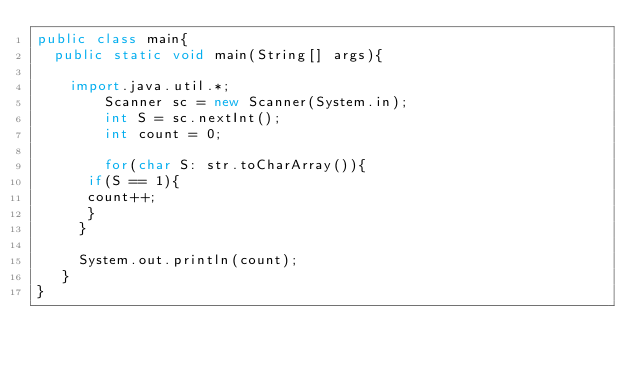<code> <loc_0><loc_0><loc_500><loc_500><_Java_>public class main{
	public static void main(String[] args){
		
		import.java.util.*;
        Scanner sc = new Scanner(System.in);
        int S = sc.nextInt();   
        int count = 0;
        
        for(char S: str.toCharArray()){
		  if(S == 1){
			count++;
		  }
	   }
	   
	   System.out.println(count);
	 }
}</code> 